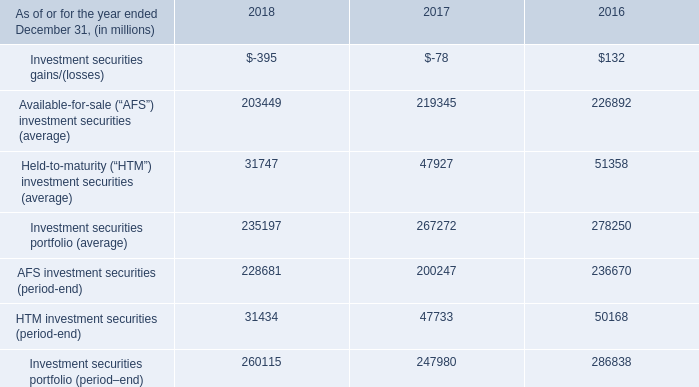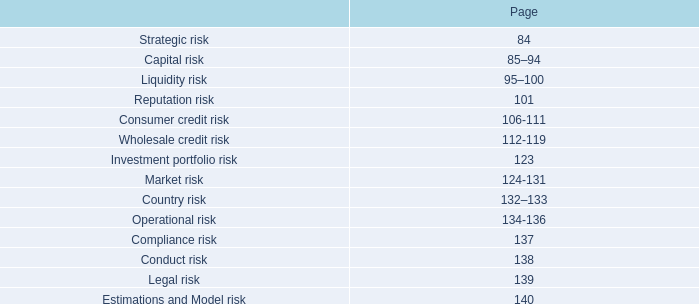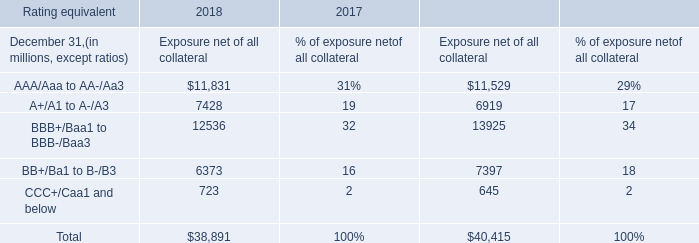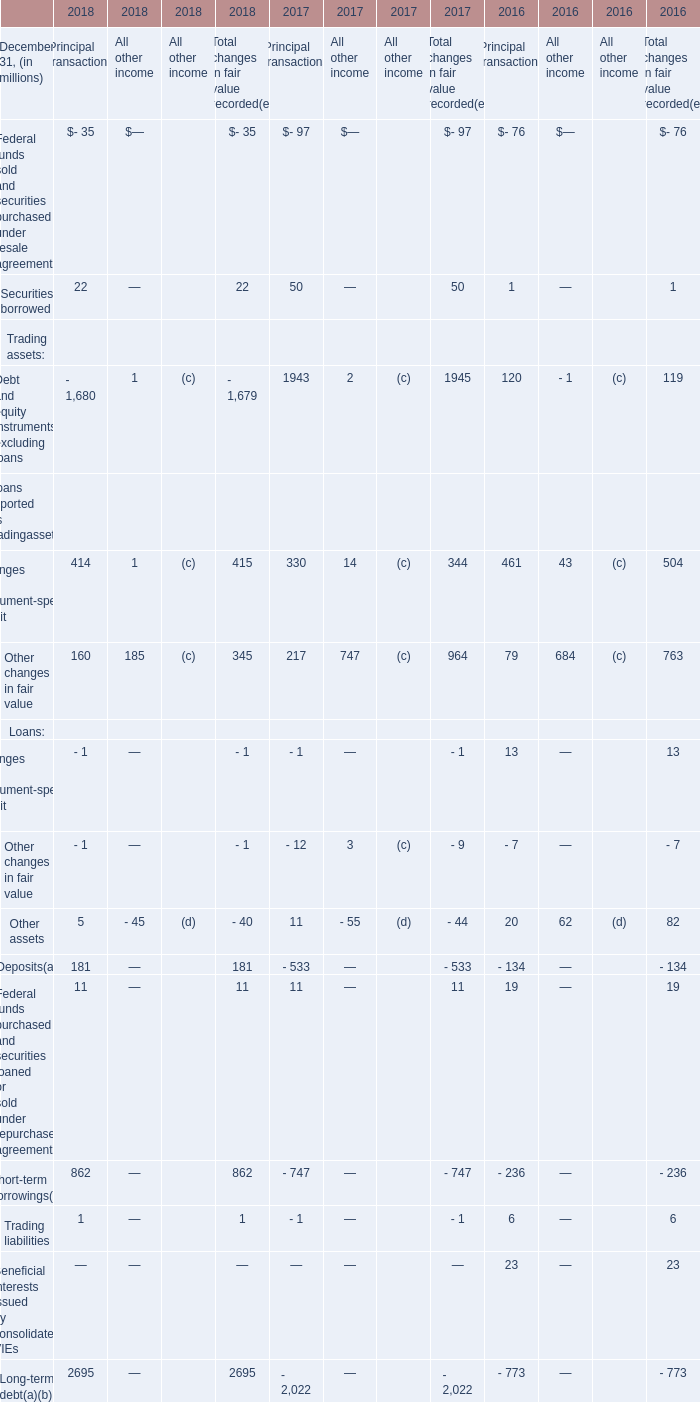As of December 31,the year when the Short-term borrowings for Principal transactions As of December 31 is the lowest,what is the amount of Other assets for Principal transactions? (in million) 
Answer: 11. 